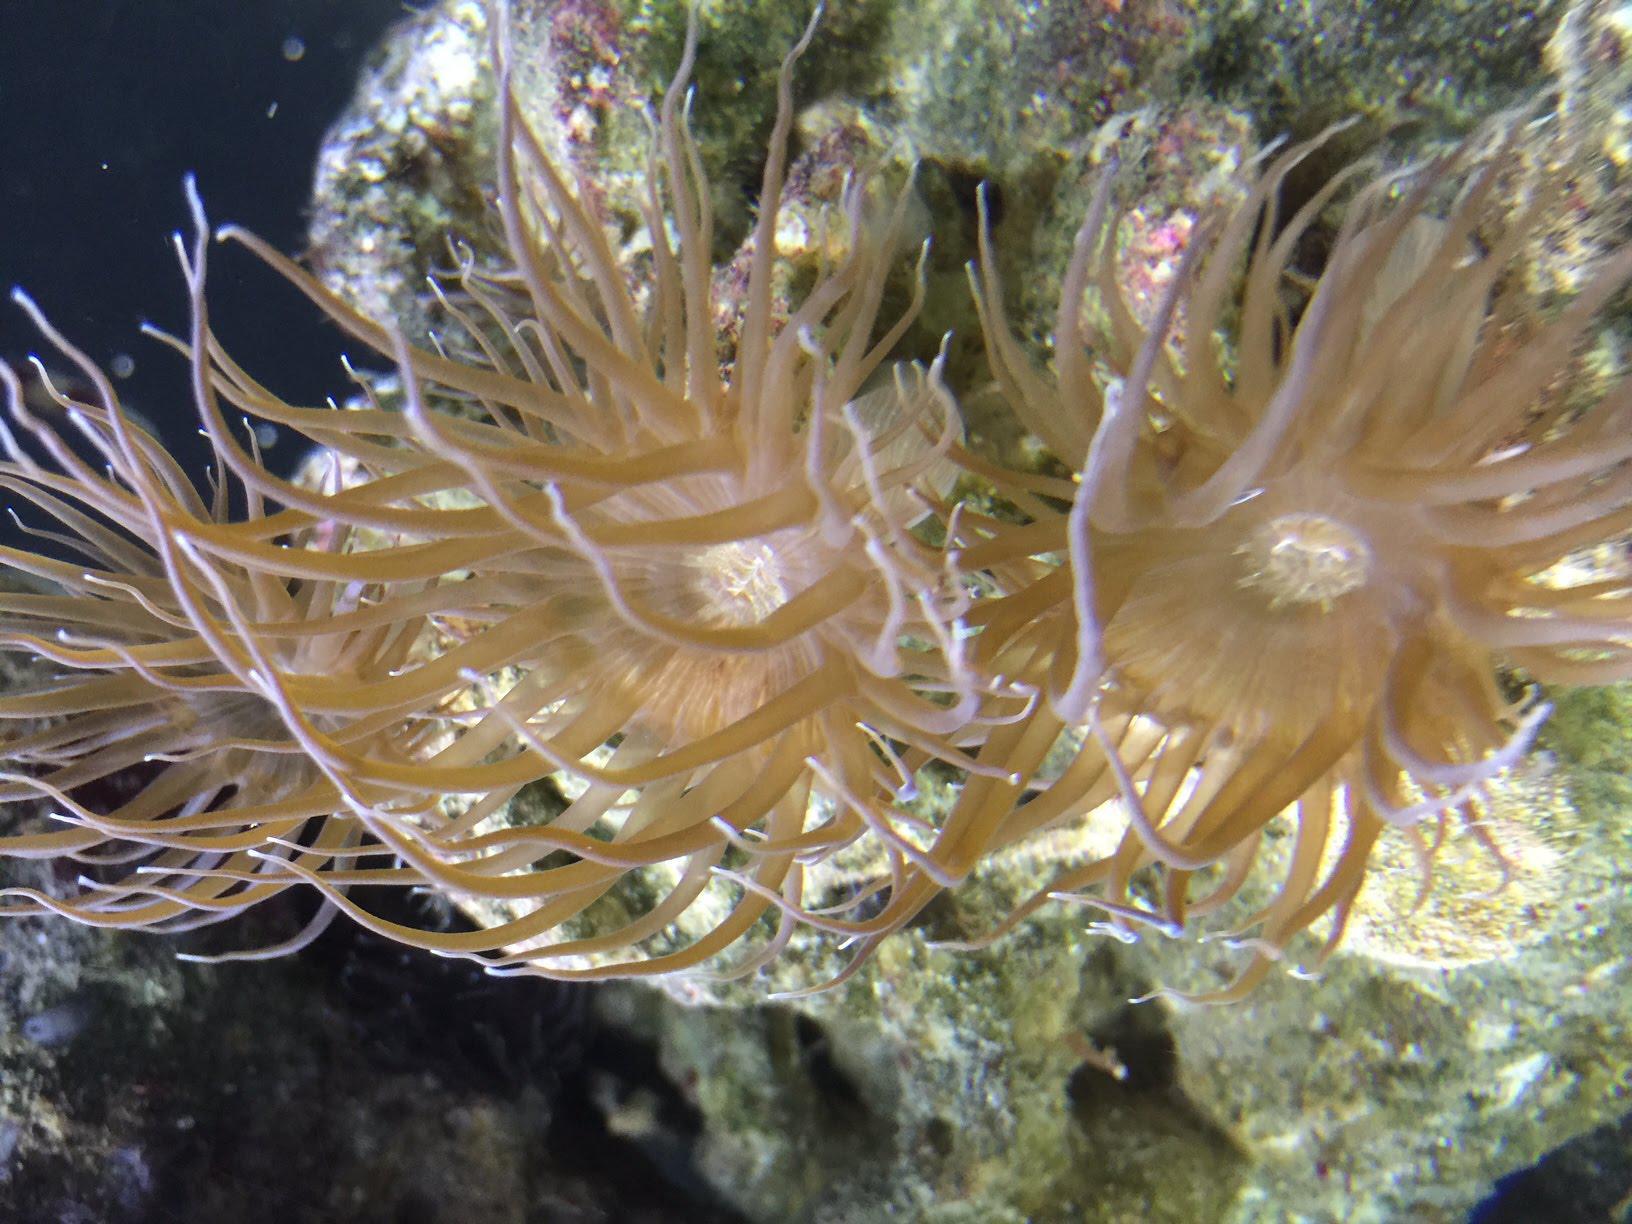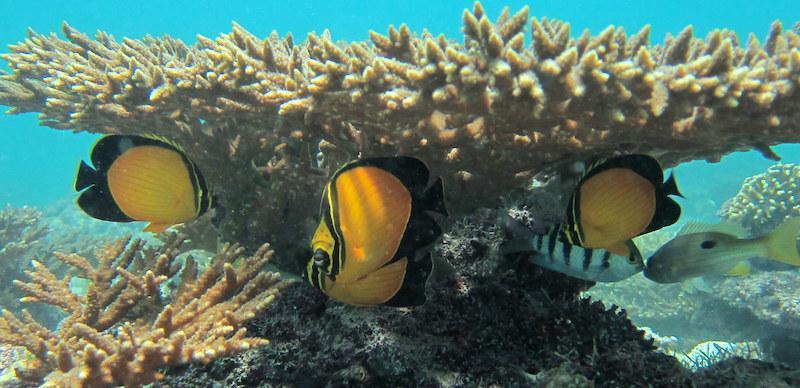The first image is the image on the left, the second image is the image on the right. For the images displayed, is the sentence "There is a crab inside an anemone." factually correct? Answer yes or no. No. The first image is the image on the left, the second image is the image on the right. For the images displayed, is the sentence "An image shows multiple fish with yellow coloration swimming near a large anemone." factually correct? Answer yes or no. Yes. 